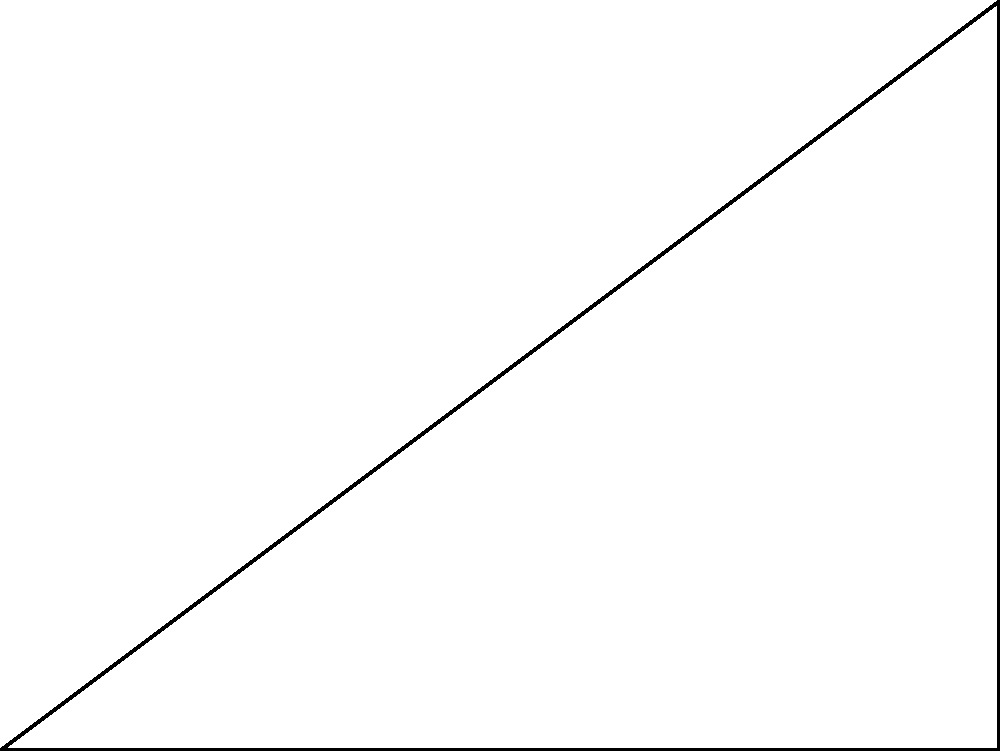In your newest escape room, you're designing a hidden door mechanism that requires a specific angle for optimal operation. The door is represented by a right-angled triangle ABC, where AB = 4 m and BC = 3 m. What is the optimal angle $\theta$ (in degrees) between the floor (AB) and the diagonal (AC) for the hidden door mechanism to function properly? To find the optimal angle $\theta$, we need to use trigonometry in the right-angled triangle ABC. Here's how we can solve this step-by-step:

1) In the right-angled triangle ABC, we know:
   - AB (adjacent to $\theta$) = 4 m
   - BC (opposite to $\theta$) = 3 m

2) We can use the tangent function to find $\theta$:

   $\tan(\theta) = \frac{\text{opposite}}{\text{adjacent}} = \frac{BC}{AB} = \frac{3}{4}$

3) To find $\theta$, we need to use the inverse tangent (arctan or $\tan^{-1}$):

   $\theta = \tan^{-1}(\frac{3}{4})$

4) Using a calculator or mathematical software:

   $\theta \approx 36.87°$

5) Round to the nearest degree:

   $\theta \approx 37°$

Therefore, the optimal angle for the hidden door mechanism is approximately 37 degrees.
Answer: $37°$ 